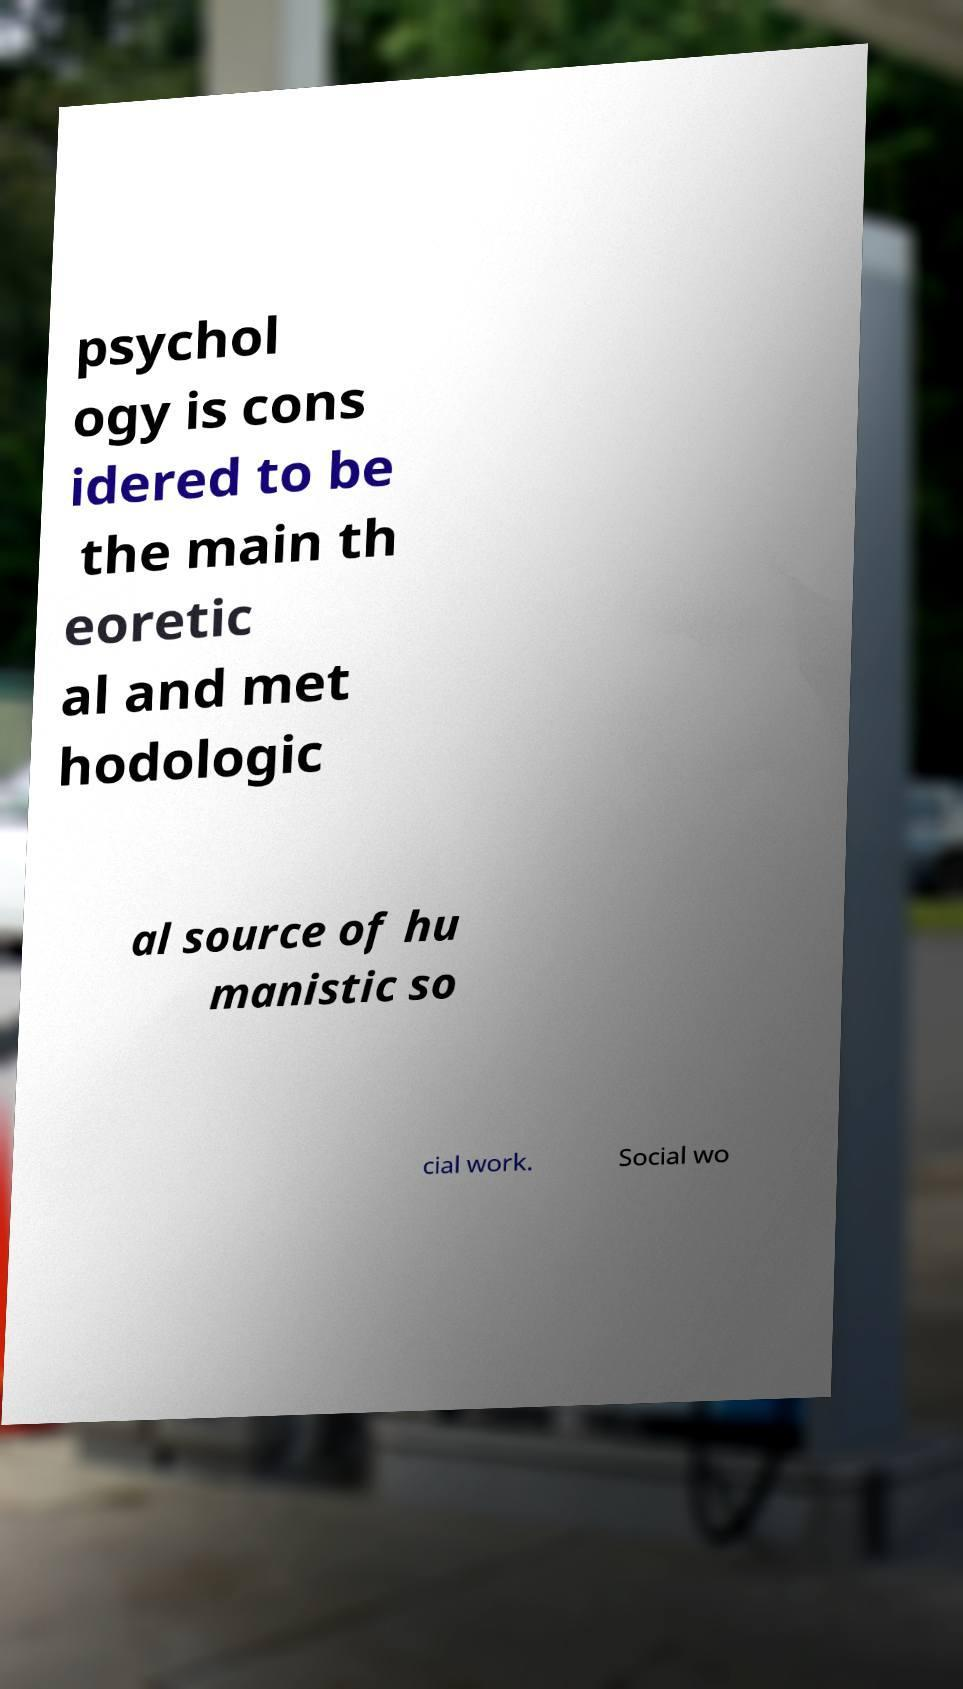For documentation purposes, I need the text within this image transcribed. Could you provide that? psychol ogy is cons idered to be the main th eoretic al and met hodologic al source of hu manistic so cial work. Social wo 